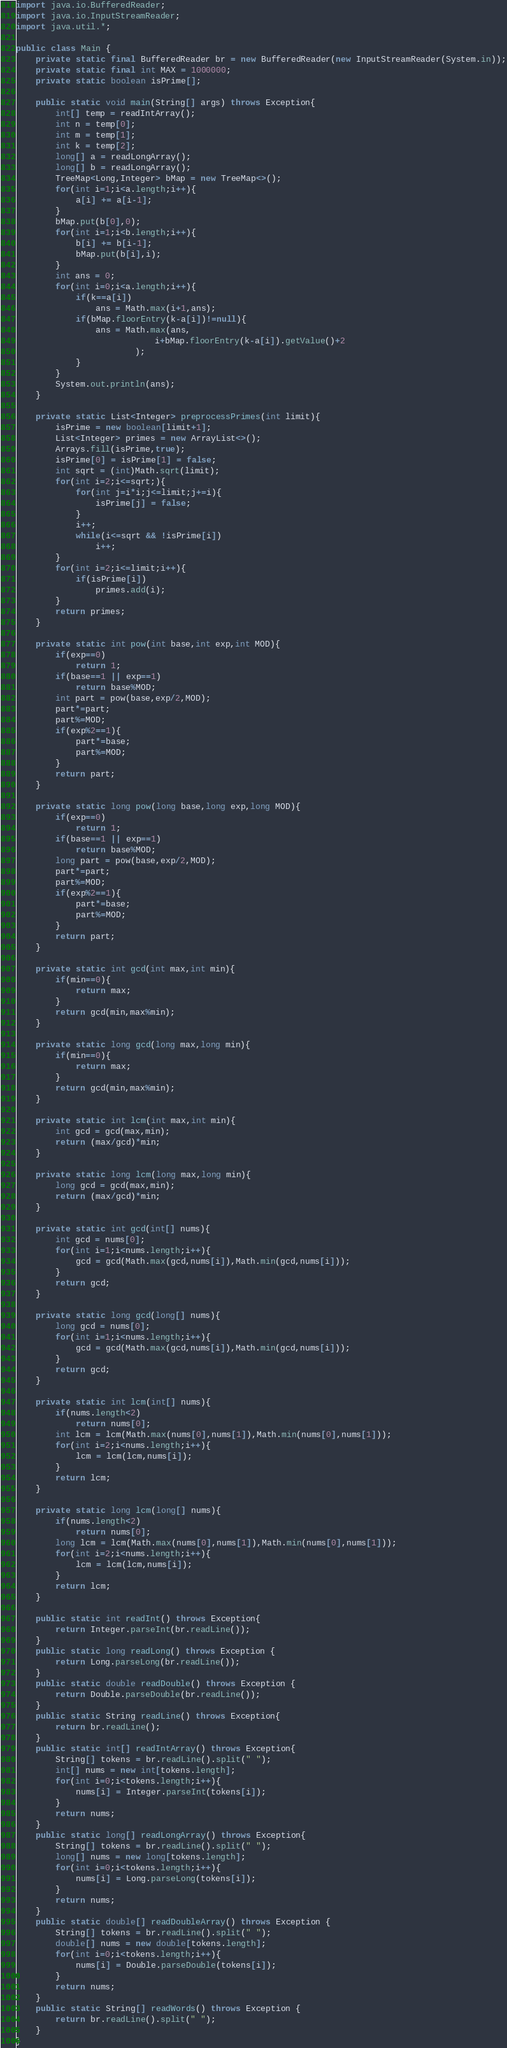Convert code to text. <code><loc_0><loc_0><loc_500><loc_500><_Java_>import java.io.BufferedReader;
import java.io.InputStreamReader;
import java.util.*;

public class Main {
    private static final BufferedReader br = new BufferedReader(new InputStreamReader(System.in));
    private static final int MAX = 1000000;
    private static boolean isPrime[];

    public static void main(String[] args) throws Exception{
        int[] temp = readIntArray();
        int n = temp[0];
        int m = temp[1];
        int k = temp[2];
        long[] a = readLongArray();
        long[] b = readLongArray();
        TreeMap<Long,Integer> bMap = new TreeMap<>();
        for(int i=1;i<a.length;i++){
            a[i] += a[i-1];
        }
        bMap.put(b[0],0);
        for(int i=1;i<b.length;i++){
            b[i] += b[i-1];
            bMap.put(b[i],i);
        }
        int ans = 0;
        for(int i=0;i<a.length;i++){
            if(k==a[i])
                ans = Math.max(i+1,ans);
            if(bMap.floorEntry(k-a[i])!=null){
                ans = Math.max(ans,
                            i+bMap.floorEntry(k-a[i]).getValue()+2
                        );
            }
        }
        System.out.println(ans);
    }

    private static List<Integer> preprocessPrimes(int limit){
        isPrime = new boolean[limit+1];
        List<Integer> primes = new ArrayList<>();
        Arrays.fill(isPrime,true);
        isPrime[0] = isPrime[1] = false;
        int sqrt = (int)Math.sqrt(limit);
        for(int i=2;i<=sqrt;){
            for(int j=i*i;j<=limit;j+=i){
                isPrime[j] = false;
            }
            i++;
            while(i<=sqrt && !isPrime[i])
                i++;
        }
        for(int i=2;i<=limit;i++){
            if(isPrime[i])
                primes.add(i);
        }
        return primes;
    }

    private static int pow(int base,int exp,int MOD){
        if(exp==0)
            return 1;
        if(base==1 || exp==1)
            return base%MOD;
        int part = pow(base,exp/2,MOD);
        part*=part;
        part%=MOD;
        if(exp%2==1){
            part*=base;
            part%=MOD;
        }
        return part;
    }

    private static long pow(long base,long exp,long MOD){
        if(exp==0)
            return 1;
        if(base==1 || exp==1)
            return base%MOD;
        long part = pow(base,exp/2,MOD);
        part*=part;
        part%=MOD;
        if(exp%2==1){
            part*=base;
            part%=MOD;
        }
        return part;
    }

    private static int gcd(int max,int min){
        if(min==0){
            return max;
        }
        return gcd(min,max%min);
    }

    private static long gcd(long max,long min){
        if(min==0){
            return max;
        }
        return gcd(min,max%min);
    }

    private static int lcm(int max,int min){
        int gcd = gcd(max,min);
        return (max/gcd)*min;
    }

    private static long lcm(long max,long min){
        long gcd = gcd(max,min);
        return (max/gcd)*min;
    }

    private static int gcd(int[] nums){
        int gcd = nums[0];
        for(int i=1;i<nums.length;i++){
            gcd = gcd(Math.max(gcd,nums[i]),Math.min(gcd,nums[i]));
        }
        return gcd;
    }

    private static long gcd(long[] nums){
        long gcd = nums[0];
        for(int i=1;i<nums.length;i++){
            gcd = gcd(Math.max(gcd,nums[i]),Math.min(gcd,nums[i]));
        }
        return gcd;
    }

    private static int lcm(int[] nums){
        if(nums.length<2)
            return nums[0];
        int lcm = lcm(Math.max(nums[0],nums[1]),Math.min(nums[0],nums[1]));
        for(int i=2;i<nums.length;i++){
            lcm = lcm(lcm,nums[i]);
        }
        return lcm;
    }

    private static long lcm(long[] nums){
        if(nums.length<2)
            return nums[0];
        long lcm = lcm(Math.max(nums[0],nums[1]),Math.min(nums[0],nums[1]));
        for(int i=2;i<nums.length;i++){
            lcm = lcm(lcm,nums[i]);
        }
        return lcm;
    }

    public static int readInt() throws Exception{
        return Integer.parseInt(br.readLine());
    }
    public static long readLong() throws Exception {
        return Long.parseLong(br.readLine());
    }
    public static double readDouble() throws Exception {
        return Double.parseDouble(br.readLine());
    }
    public static String readLine() throws Exception{
        return br.readLine();
    }
    public static int[] readIntArray() throws Exception{
        String[] tokens = br.readLine().split(" ");
        int[] nums = new int[tokens.length];
        for(int i=0;i<tokens.length;i++){
            nums[i] = Integer.parseInt(tokens[i]);
        }
        return nums;
    }
    public static long[] readLongArray() throws Exception{
        String[] tokens = br.readLine().split(" ");
        long[] nums = new long[tokens.length];
        for(int i=0;i<tokens.length;i++){
            nums[i] = Long.parseLong(tokens[i]);
        }
        return nums;
    }
    public static double[] readDoubleArray() throws Exception {
        String[] tokens = br.readLine().split(" ");
        double[] nums = new double[tokens.length];
        for(int i=0;i<tokens.length;i++){
            nums[i] = Double.parseDouble(tokens[i]);
        }
        return nums;
    }
    public static String[] readWords() throws Exception {
        return br.readLine().split(" ");
    }
}
</code> 